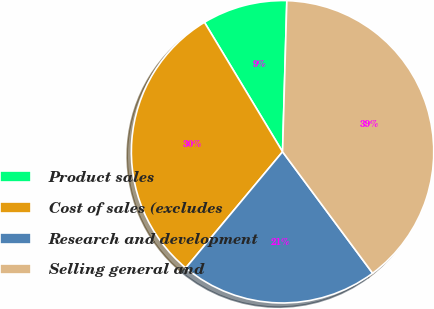<chart> <loc_0><loc_0><loc_500><loc_500><pie_chart><fcel>Product sales<fcel>Cost of sales (excludes<fcel>Research and development<fcel>Selling general and<nl><fcel>9.09%<fcel>30.3%<fcel>21.21%<fcel>39.39%<nl></chart> 